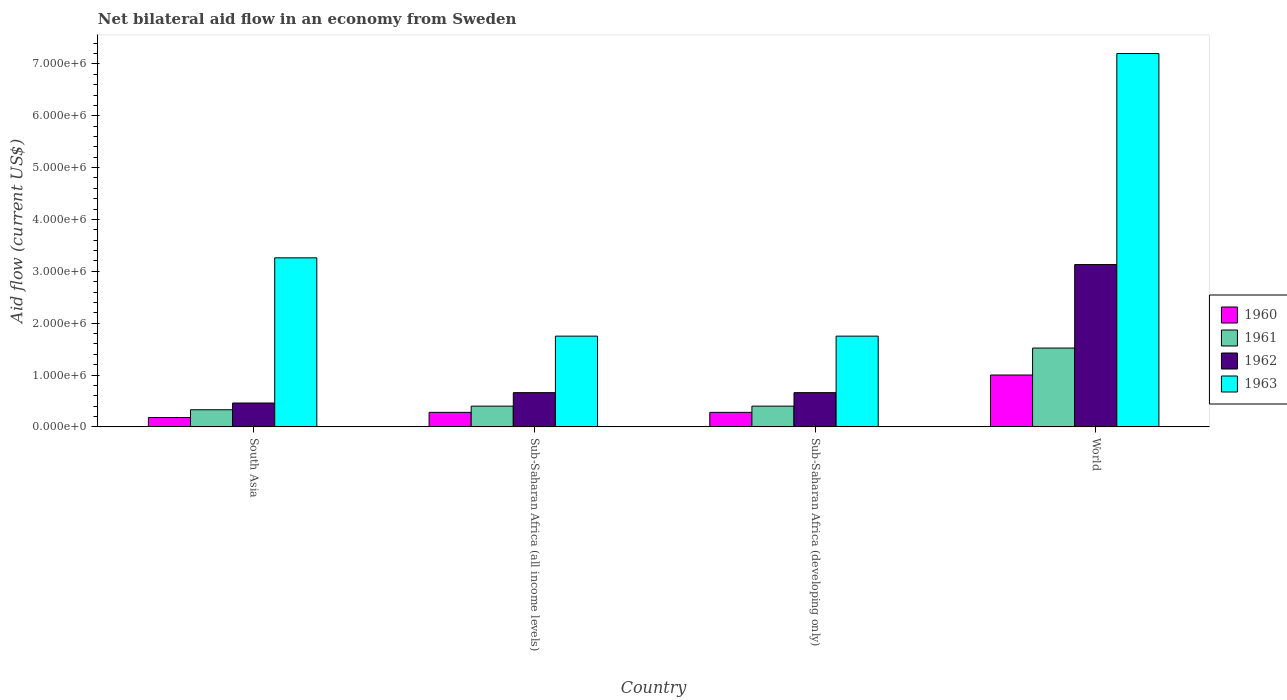How many different coloured bars are there?
Your answer should be very brief. 4. Are the number of bars per tick equal to the number of legend labels?
Provide a short and direct response. Yes. How many bars are there on the 1st tick from the left?
Ensure brevity in your answer.  4. What is the label of the 1st group of bars from the left?
Provide a succinct answer. South Asia. In how many cases, is the number of bars for a given country not equal to the number of legend labels?
Your answer should be very brief. 0. What is the net bilateral aid flow in 1963 in World?
Ensure brevity in your answer.  7.20e+06. Across all countries, what is the maximum net bilateral aid flow in 1961?
Make the answer very short. 1.52e+06. Across all countries, what is the minimum net bilateral aid flow in 1960?
Your answer should be compact. 1.80e+05. In which country was the net bilateral aid flow in 1963 maximum?
Your response must be concise. World. What is the total net bilateral aid flow in 1960 in the graph?
Keep it short and to the point. 1.74e+06. What is the difference between the net bilateral aid flow in 1962 in Sub-Saharan Africa (all income levels) and that in World?
Keep it short and to the point. -2.47e+06. What is the difference between the net bilateral aid flow in 1961 in South Asia and the net bilateral aid flow in 1962 in Sub-Saharan Africa (all income levels)?
Offer a terse response. -3.30e+05. What is the average net bilateral aid flow in 1962 per country?
Provide a succinct answer. 1.23e+06. What is the difference between the net bilateral aid flow of/in 1963 and net bilateral aid flow of/in 1961 in Sub-Saharan Africa (all income levels)?
Offer a terse response. 1.35e+06. Is the difference between the net bilateral aid flow in 1963 in Sub-Saharan Africa (developing only) and World greater than the difference between the net bilateral aid flow in 1961 in Sub-Saharan Africa (developing only) and World?
Offer a terse response. No. What is the difference between the highest and the second highest net bilateral aid flow in 1960?
Keep it short and to the point. 7.20e+05. What is the difference between the highest and the lowest net bilateral aid flow in 1960?
Make the answer very short. 8.20e+05. In how many countries, is the net bilateral aid flow in 1962 greater than the average net bilateral aid flow in 1962 taken over all countries?
Your answer should be very brief. 1. Is it the case that in every country, the sum of the net bilateral aid flow in 1961 and net bilateral aid flow in 1960 is greater than the sum of net bilateral aid flow in 1962 and net bilateral aid flow in 1963?
Your answer should be compact. No. What does the 3rd bar from the left in Sub-Saharan Africa (all income levels) represents?
Your response must be concise. 1962. How many bars are there?
Offer a very short reply. 16. How many countries are there in the graph?
Keep it short and to the point. 4. Are the values on the major ticks of Y-axis written in scientific E-notation?
Provide a short and direct response. Yes. Does the graph contain any zero values?
Provide a short and direct response. No. Does the graph contain grids?
Offer a terse response. No. How many legend labels are there?
Keep it short and to the point. 4. How are the legend labels stacked?
Your response must be concise. Vertical. What is the title of the graph?
Provide a short and direct response. Net bilateral aid flow in an economy from Sweden. Does "1993" appear as one of the legend labels in the graph?
Make the answer very short. No. What is the label or title of the X-axis?
Give a very brief answer. Country. What is the Aid flow (current US$) of 1963 in South Asia?
Offer a very short reply. 3.26e+06. What is the Aid flow (current US$) in 1962 in Sub-Saharan Africa (all income levels)?
Provide a short and direct response. 6.60e+05. What is the Aid flow (current US$) in 1963 in Sub-Saharan Africa (all income levels)?
Offer a very short reply. 1.75e+06. What is the Aid flow (current US$) in 1962 in Sub-Saharan Africa (developing only)?
Provide a short and direct response. 6.60e+05. What is the Aid flow (current US$) in 1963 in Sub-Saharan Africa (developing only)?
Offer a terse response. 1.75e+06. What is the Aid flow (current US$) in 1960 in World?
Ensure brevity in your answer.  1.00e+06. What is the Aid flow (current US$) of 1961 in World?
Your answer should be very brief. 1.52e+06. What is the Aid flow (current US$) in 1962 in World?
Provide a succinct answer. 3.13e+06. What is the Aid flow (current US$) of 1963 in World?
Provide a short and direct response. 7.20e+06. Across all countries, what is the maximum Aid flow (current US$) in 1960?
Provide a succinct answer. 1.00e+06. Across all countries, what is the maximum Aid flow (current US$) of 1961?
Ensure brevity in your answer.  1.52e+06. Across all countries, what is the maximum Aid flow (current US$) of 1962?
Make the answer very short. 3.13e+06. Across all countries, what is the maximum Aid flow (current US$) in 1963?
Ensure brevity in your answer.  7.20e+06. Across all countries, what is the minimum Aid flow (current US$) in 1962?
Your response must be concise. 4.60e+05. Across all countries, what is the minimum Aid flow (current US$) in 1963?
Your answer should be very brief. 1.75e+06. What is the total Aid flow (current US$) in 1960 in the graph?
Give a very brief answer. 1.74e+06. What is the total Aid flow (current US$) in 1961 in the graph?
Offer a terse response. 2.65e+06. What is the total Aid flow (current US$) of 1962 in the graph?
Make the answer very short. 4.91e+06. What is the total Aid flow (current US$) in 1963 in the graph?
Make the answer very short. 1.40e+07. What is the difference between the Aid flow (current US$) in 1963 in South Asia and that in Sub-Saharan Africa (all income levels)?
Ensure brevity in your answer.  1.51e+06. What is the difference between the Aid flow (current US$) of 1960 in South Asia and that in Sub-Saharan Africa (developing only)?
Provide a succinct answer. -1.00e+05. What is the difference between the Aid flow (current US$) of 1963 in South Asia and that in Sub-Saharan Africa (developing only)?
Offer a very short reply. 1.51e+06. What is the difference between the Aid flow (current US$) in 1960 in South Asia and that in World?
Make the answer very short. -8.20e+05. What is the difference between the Aid flow (current US$) in 1961 in South Asia and that in World?
Provide a succinct answer. -1.19e+06. What is the difference between the Aid flow (current US$) in 1962 in South Asia and that in World?
Provide a short and direct response. -2.67e+06. What is the difference between the Aid flow (current US$) of 1963 in South Asia and that in World?
Your answer should be compact. -3.94e+06. What is the difference between the Aid flow (current US$) of 1960 in Sub-Saharan Africa (all income levels) and that in Sub-Saharan Africa (developing only)?
Offer a terse response. 0. What is the difference between the Aid flow (current US$) of 1961 in Sub-Saharan Africa (all income levels) and that in Sub-Saharan Africa (developing only)?
Your response must be concise. 0. What is the difference between the Aid flow (current US$) in 1960 in Sub-Saharan Africa (all income levels) and that in World?
Keep it short and to the point. -7.20e+05. What is the difference between the Aid flow (current US$) in 1961 in Sub-Saharan Africa (all income levels) and that in World?
Offer a terse response. -1.12e+06. What is the difference between the Aid flow (current US$) of 1962 in Sub-Saharan Africa (all income levels) and that in World?
Give a very brief answer. -2.47e+06. What is the difference between the Aid flow (current US$) in 1963 in Sub-Saharan Africa (all income levels) and that in World?
Provide a short and direct response. -5.45e+06. What is the difference between the Aid flow (current US$) of 1960 in Sub-Saharan Africa (developing only) and that in World?
Give a very brief answer. -7.20e+05. What is the difference between the Aid flow (current US$) of 1961 in Sub-Saharan Africa (developing only) and that in World?
Keep it short and to the point. -1.12e+06. What is the difference between the Aid flow (current US$) in 1962 in Sub-Saharan Africa (developing only) and that in World?
Give a very brief answer. -2.47e+06. What is the difference between the Aid flow (current US$) of 1963 in Sub-Saharan Africa (developing only) and that in World?
Your answer should be compact. -5.45e+06. What is the difference between the Aid flow (current US$) of 1960 in South Asia and the Aid flow (current US$) of 1961 in Sub-Saharan Africa (all income levels)?
Provide a short and direct response. -2.20e+05. What is the difference between the Aid flow (current US$) in 1960 in South Asia and the Aid flow (current US$) in 1962 in Sub-Saharan Africa (all income levels)?
Your response must be concise. -4.80e+05. What is the difference between the Aid flow (current US$) in 1960 in South Asia and the Aid flow (current US$) in 1963 in Sub-Saharan Africa (all income levels)?
Provide a succinct answer. -1.57e+06. What is the difference between the Aid flow (current US$) of 1961 in South Asia and the Aid flow (current US$) of 1962 in Sub-Saharan Africa (all income levels)?
Make the answer very short. -3.30e+05. What is the difference between the Aid flow (current US$) of 1961 in South Asia and the Aid flow (current US$) of 1963 in Sub-Saharan Africa (all income levels)?
Your answer should be very brief. -1.42e+06. What is the difference between the Aid flow (current US$) of 1962 in South Asia and the Aid flow (current US$) of 1963 in Sub-Saharan Africa (all income levels)?
Your answer should be compact. -1.29e+06. What is the difference between the Aid flow (current US$) of 1960 in South Asia and the Aid flow (current US$) of 1962 in Sub-Saharan Africa (developing only)?
Your answer should be very brief. -4.80e+05. What is the difference between the Aid flow (current US$) of 1960 in South Asia and the Aid flow (current US$) of 1963 in Sub-Saharan Africa (developing only)?
Your response must be concise. -1.57e+06. What is the difference between the Aid flow (current US$) in 1961 in South Asia and the Aid flow (current US$) in 1962 in Sub-Saharan Africa (developing only)?
Your answer should be compact. -3.30e+05. What is the difference between the Aid flow (current US$) of 1961 in South Asia and the Aid flow (current US$) of 1963 in Sub-Saharan Africa (developing only)?
Ensure brevity in your answer.  -1.42e+06. What is the difference between the Aid flow (current US$) in 1962 in South Asia and the Aid flow (current US$) in 1963 in Sub-Saharan Africa (developing only)?
Your answer should be compact. -1.29e+06. What is the difference between the Aid flow (current US$) in 1960 in South Asia and the Aid flow (current US$) in 1961 in World?
Offer a very short reply. -1.34e+06. What is the difference between the Aid flow (current US$) in 1960 in South Asia and the Aid flow (current US$) in 1962 in World?
Ensure brevity in your answer.  -2.95e+06. What is the difference between the Aid flow (current US$) of 1960 in South Asia and the Aid flow (current US$) of 1963 in World?
Keep it short and to the point. -7.02e+06. What is the difference between the Aid flow (current US$) in 1961 in South Asia and the Aid flow (current US$) in 1962 in World?
Offer a very short reply. -2.80e+06. What is the difference between the Aid flow (current US$) of 1961 in South Asia and the Aid flow (current US$) of 1963 in World?
Make the answer very short. -6.87e+06. What is the difference between the Aid flow (current US$) of 1962 in South Asia and the Aid flow (current US$) of 1963 in World?
Ensure brevity in your answer.  -6.74e+06. What is the difference between the Aid flow (current US$) of 1960 in Sub-Saharan Africa (all income levels) and the Aid flow (current US$) of 1962 in Sub-Saharan Africa (developing only)?
Provide a short and direct response. -3.80e+05. What is the difference between the Aid flow (current US$) of 1960 in Sub-Saharan Africa (all income levels) and the Aid flow (current US$) of 1963 in Sub-Saharan Africa (developing only)?
Give a very brief answer. -1.47e+06. What is the difference between the Aid flow (current US$) in 1961 in Sub-Saharan Africa (all income levels) and the Aid flow (current US$) in 1962 in Sub-Saharan Africa (developing only)?
Make the answer very short. -2.60e+05. What is the difference between the Aid flow (current US$) of 1961 in Sub-Saharan Africa (all income levels) and the Aid flow (current US$) of 1963 in Sub-Saharan Africa (developing only)?
Offer a very short reply. -1.35e+06. What is the difference between the Aid flow (current US$) of 1962 in Sub-Saharan Africa (all income levels) and the Aid flow (current US$) of 1963 in Sub-Saharan Africa (developing only)?
Offer a terse response. -1.09e+06. What is the difference between the Aid flow (current US$) of 1960 in Sub-Saharan Africa (all income levels) and the Aid flow (current US$) of 1961 in World?
Offer a very short reply. -1.24e+06. What is the difference between the Aid flow (current US$) in 1960 in Sub-Saharan Africa (all income levels) and the Aid flow (current US$) in 1962 in World?
Offer a terse response. -2.85e+06. What is the difference between the Aid flow (current US$) in 1960 in Sub-Saharan Africa (all income levels) and the Aid flow (current US$) in 1963 in World?
Your answer should be very brief. -6.92e+06. What is the difference between the Aid flow (current US$) in 1961 in Sub-Saharan Africa (all income levels) and the Aid flow (current US$) in 1962 in World?
Provide a short and direct response. -2.73e+06. What is the difference between the Aid flow (current US$) of 1961 in Sub-Saharan Africa (all income levels) and the Aid flow (current US$) of 1963 in World?
Keep it short and to the point. -6.80e+06. What is the difference between the Aid flow (current US$) in 1962 in Sub-Saharan Africa (all income levels) and the Aid flow (current US$) in 1963 in World?
Your answer should be compact. -6.54e+06. What is the difference between the Aid flow (current US$) of 1960 in Sub-Saharan Africa (developing only) and the Aid flow (current US$) of 1961 in World?
Provide a succinct answer. -1.24e+06. What is the difference between the Aid flow (current US$) of 1960 in Sub-Saharan Africa (developing only) and the Aid flow (current US$) of 1962 in World?
Offer a terse response. -2.85e+06. What is the difference between the Aid flow (current US$) in 1960 in Sub-Saharan Africa (developing only) and the Aid flow (current US$) in 1963 in World?
Your answer should be very brief. -6.92e+06. What is the difference between the Aid flow (current US$) in 1961 in Sub-Saharan Africa (developing only) and the Aid flow (current US$) in 1962 in World?
Keep it short and to the point. -2.73e+06. What is the difference between the Aid flow (current US$) of 1961 in Sub-Saharan Africa (developing only) and the Aid flow (current US$) of 1963 in World?
Provide a short and direct response. -6.80e+06. What is the difference between the Aid flow (current US$) in 1962 in Sub-Saharan Africa (developing only) and the Aid flow (current US$) in 1963 in World?
Your response must be concise. -6.54e+06. What is the average Aid flow (current US$) in 1960 per country?
Your answer should be compact. 4.35e+05. What is the average Aid flow (current US$) in 1961 per country?
Your answer should be compact. 6.62e+05. What is the average Aid flow (current US$) in 1962 per country?
Give a very brief answer. 1.23e+06. What is the average Aid flow (current US$) in 1963 per country?
Give a very brief answer. 3.49e+06. What is the difference between the Aid flow (current US$) of 1960 and Aid flow (current US$) of 1961 in South Asia?
Offer a terse response. -1.50e+05. What is the difference between the Aid flow (current US$) of 1960 and Aid flow (current US$) of 1962 in South Asia?
Ensure brevity in your answer.  -2.80e+05. What is the difference between the Aid flow (current US$) in 1960 and Aid flow (current US$) in 1963 in South Asia?
Offer a terse response. -3.08e+06. What is the difference between the Aid flow (current US$) in 1961 and Aid flow (current US$) in 1963 in South Asia?
Give a very brief answer. -2.93e+06. What is the difference between the Aid flow (current US$) of 1962 and Aid flow (current US$) of 1963 in South Asia?
Give a very brief answer. -2.80e+06. What is the difference between the Aid flow (current US$) of 1960 and Aid flow (current US$) of 1961 in Sub-Saharan Africa (all income levels)?
Your response must be concise. -1.20e+05. What is the difference between the Aid flow (current US$) in 1960 and Aid flow (current US$) in 1962 in Sub-Saharan Africa (all income levels)?
Your answer should be very brief. -3.80e+05. What is the difference between the Aid flow (current US$) of 1960 and Aid flow (current US$) of 1963 in Sub-Saharan Africa (all income levels)?
Give a very brief answer. -1.47e+06. What is the difference between the Aid flow (current US$) of 1961 and Aid flow (current US$) of 1963 in Sub-Saharan Africa (all income levels)?
Give a very brief answer. -1.35e+06. What is the difference between the Aid flow (current US$) of 1962 and Aid flow (current US$) of 1963 in Sub-Saharan Africa (all income levels)?
Give a very brief answer. -1.09e+06. What is the difference between the Aid flow (current US$) in 1960 and Aid flow (current US$) in 1962 in Sub-Saharan Africa (developing only)?
Keep it short and to the point. -3.80e+05. What is the difference between the Aid flow (current US$) of 1960 and Aid flow (current US$) of 1963 in Sub-Saharan Africa (developing only)?
Provide a short and direct response. -1.47e+06. What is the difference between the Aid flow (current US$) in 1961 and Aid flow (current US$) in 1963 in Sub-Saharan Africa (developing only)?
Give a very brief answer. -1.35e+06. What is the difference between the Aid flow (current US$) of 1962 and Aid flow (current US$) of 1963 in Sub-Saharan Africa (developing only)?
Make the answer very short. -1.09e+06. What is the difference between the Aid flow (current US$) in 1960 and Aid flow (current US$) in 1961 in World?
Provide a succinct answer. -5.20e+05. What is the difference between the Aid flow (current US$) of 1960 and Aid flow (current US$) of 1962 in World?
Provide a short and direct response. -2.13e+06. What is the difference between the Aid flow (current US$) of 1960 and Aid flow (current US$) of 1963 in World?
Keep it short and to the point. -6.20e+06. What is the difference between the Aid flow (current US$) of 1961 and Aid flow (current US$) of 1962 in World?
Your response must be concise. -1.61e+06. What is the difference between the Aid flow (current US$) in 1961 and Aid flow (current US$) in 1963 in World?
Provide a short and direct response. -5.68e+06. What is the difference between the Aid flow (current US$) of 1962 and Aid flow (current US$) of 1963 in World?
Ensure brevity in your answer.  -4.07e+06. What is the ratio of the Aid flow (current US$) in 1960 in South Asia to that in Sub-Saharan Africa (all income levels)?
Provide a short and direct response. 0.64. What is the ratio of the Aid flow (current US$) in 1961 in South Asia to that in Sub-Saharan Africa (all income levels)?
Your response must be concise. 0.82. What is the ratio of the Aid flow (current US$) of 1962 in South Asia to that in Sub-Saharan Africa (all income levels)?
Ensure brevity in your answer.  0.7. What is the ratio of the Aid flow (current US$) in 1963 in South Asia to that in Sub-Saharan Africa (all income levels)?
Give a very brief answer. 1.86. What is the ratio of the Aid flow (current US$) of 1960 in South Asia to that in Sub-Saharan Africa (developing only)?
Give a very brief answer. 0.64. What is the ratio of the Aid flow (current US$) of 1961 in South Asia to that in Sub-Saharan Africa (developing only)?
Make the answer very short. 0.82. What is the ratio of the Aid flow (current US$) in 1962 in South Asia to that in Sub-Saharan Africa (developing only)?
Offer a very short reply. 0.7. What is the ratio of the Aid flow (current US$) in 1963 in South Asia to that in Sub-Saharan Africa (developing only)?
Make the answer very short. 1.86. What is the ratio of the Aid flow (current US$) of 1960 in South Asia to that in World?
Ensure brevity in your answer.  0.18. What is the ratio of the Aid flow (current US$) of 1961 in South Asia to that in World?
Make the answer very short. 0.22. What is the ratio of the Aid flow (current US$) in 1962 in South Asia to that in World?
Offer a terse response. 0.15. What is the ratio of the Aid flow (current US$) of 1963 in South Asia to that in World?
Your answer should be very brief. 0.45. What is the ratio of the Aid flow (current US$) of 1960 in Sub-Saharan Africa (all income levels) to that in Sub-Saharan Africa (developing only)?
Keep it short and to the point. 1. What is the ratio of the Aid flow (current US$) of 1961 in Sub-Saharan Africa (all income levels) to that in Sub-Saharan Africa (developing only)?
Keep it short and to the point. 1. What is the ratio of the Aid flow (current US$) in 1960 in Sub-Saharan Africa (all income levels) to that in World?
Your response must be concise. 0.28. What is the ratio of the Aid flow (current US$) in 1961 in Sub-Saharan Africa (all income levels) to that in World?
Your answer should be compact. 0.26. What is the ratio of the Aid flow (current US$) in 1962 in Sub-Saharan Africa (all income levels) to that in World?
Provide a succinct answer. 0.21. What is the ratio of the Aid flow (current US$) of 1963 in Sub-Saharan Africa (all income levels) to that in World?
Provide a succinct answer. 0.24. What is the ratio of the Aid flow (current US$) of 1960 in Sub-Saharan Africa (developing only) to that in World?
Offer a very short reply. 0.28. What is the ratio of the Aid flow (current US$) of 1961 in Sub-Saharan Africa (developing only) to that in World?
Provide a succinct answer. 0.26. What is the ratio of the Aid flow (current US$) in 1962 in Sub-Saharan Africa (developing only) to that in World?
Your response must be concise. 0.21. What is the ratio of the Aid flow (current US$) of 1963 in Sub-Saharan Africa (developing only) to that in World?
Your answer should be compact. 0.24. What is the difference between the highest and the second highest Aid flow (current US$) in 1960?
Give a very brief answer. 7.20e+05. What is the difference between the highest and the second highest Aid flow (current US$) of 1961?
Keep it short and to the point. 1.12e+06. What is the difference between the highest and the second highest Aid flow (current US$) in 1962?
Keep it short and to the point. 2.47e+06. What is the difference between the highest and the second highest Aid flow (current US$) in 1963?
Offer a terse response. 3.94e+06. What is the difference between the highest and the lowest Aid flow (current US$) in 1960?
Offer a very short reply. 8.20e+05. What is the difference between the highest and the lowest Aid flow (current US$) in 1961?
Ensure brevity in your answer.  1.19e+06. What is the difference between the highest and the lowest Aid flow (current US$) in 1962?
Offer a terse response. 2.67e+06. What is the difference between the highest and the lowest Aid flow (current US$) in 1963?
Provide a succinct answer. 5.45e+06. 